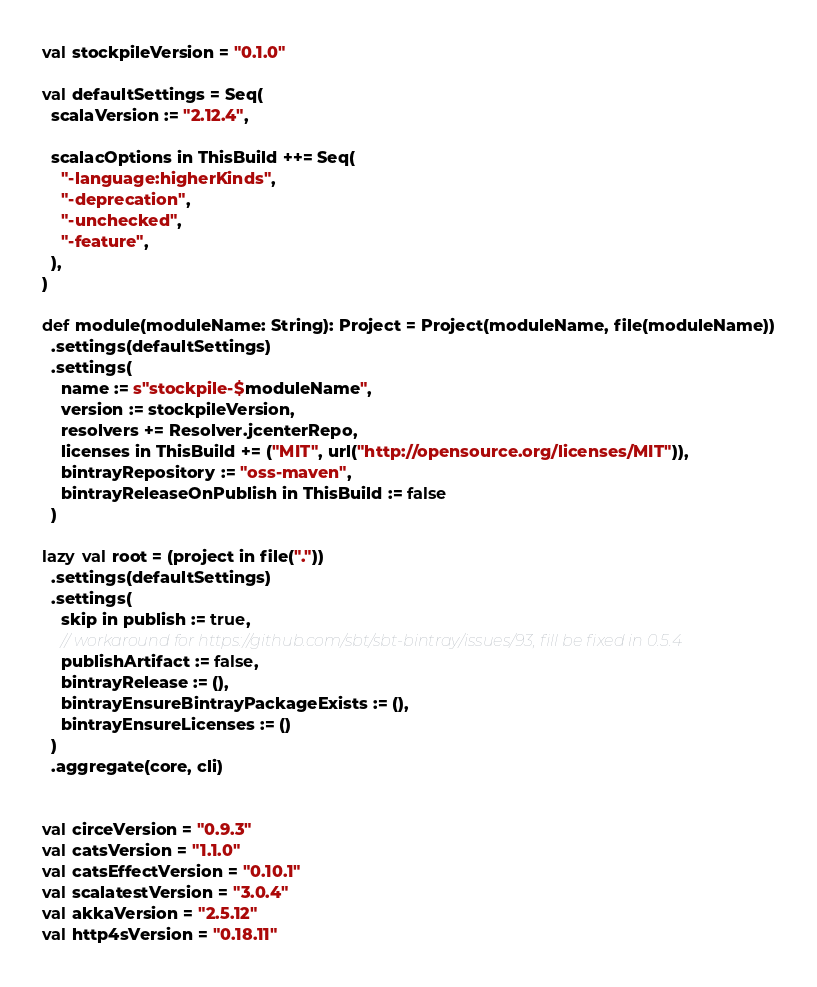<code> <loc_0><loc_0><loc_500><loc_500><_Scala_>val stockpileVersion = "0.1.0"

val defaultSettings = Seq(
  scalaVersion := "2.12.4",

  scalacOptions in ThisBuild ++= Seq(
    "-language:higherKinds",
    "-deprecation",
    "-unchecked",
    "-feature",
  ),
)

def module(moduleName: String): Project = Project(moduleName, file(moduleName))
  .settings(defaultSettings)
  .settings(
    name := s"stockpile-$moduleName",
    version := stockpileVersion,
    resolvers += Resolver.jcenterRepo,
    licenses in ThisBuild += ("MIT", url("http://opensource.org/licenses/MIT")),
    bintrayRepository := "oss-maven",
    bintrayReleaseOnPublish in ThisBuild := false
  )

lazy val root = (project in file("."))
  .settings(defaultSettings)
  .settings(
    skip in publish := true,
    // workaround for https://github.com/sbt/sbt-bintray/issues/93, fill be fixed in 0.5.4
    publishArtifact := false,
    bintrayRelease := (),
    bintrayEnsureBintrayPackageExists := (),
    bintrayEnsureLicenses := ()
  )
  .aggregate(core, cli)


val circeVersion = "0.9.3"
val catsVersion = "1.1.0"
val catsEffectVersion = "0.10.1"
val scalatestVersion = "3.0.4"
val akkaVersion = "2.5.12"
val http4sVersion = "0.18.11"
</code> 